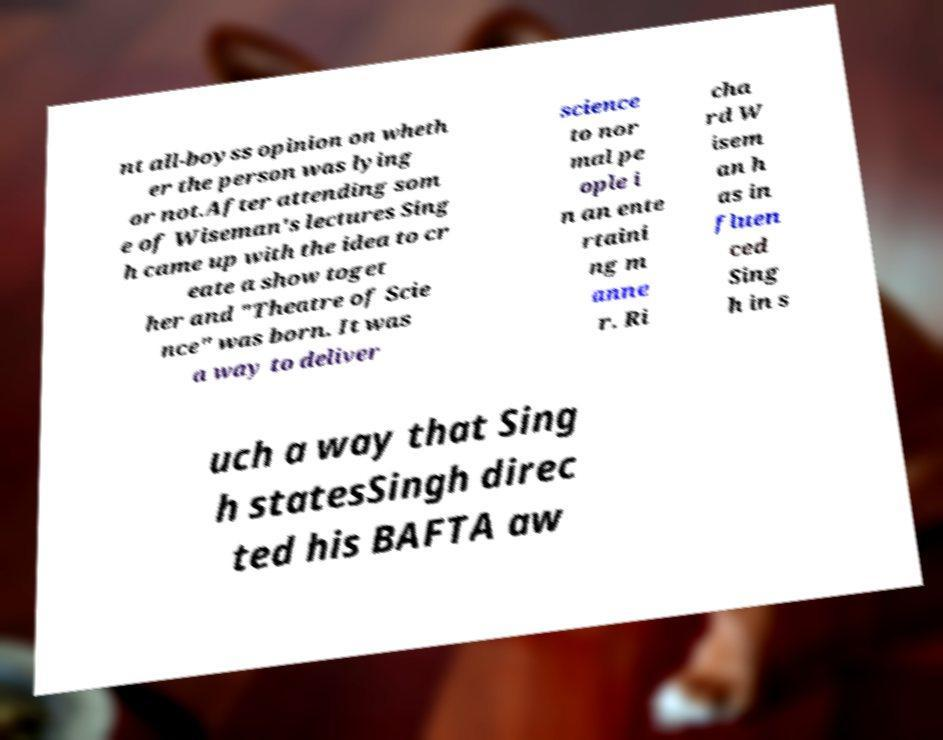For documentation purposes, I need the text within this image transcribed. Could you provide that? nt all-boyss opinion on wheth er the person was lying or not.After attending som e of Wiseman's lectures Sing h came up with the idea to cr eate a show toget her and "Theatre of Scie nce" was born. It was a way to deliver science to nor mal pe ople i n an ente rtaini ng m anne r. Ri cha rd W isem an h as in fluen ced Sing h in s uch a way that Sing h statesSingh direc ted his BAFTA aw 